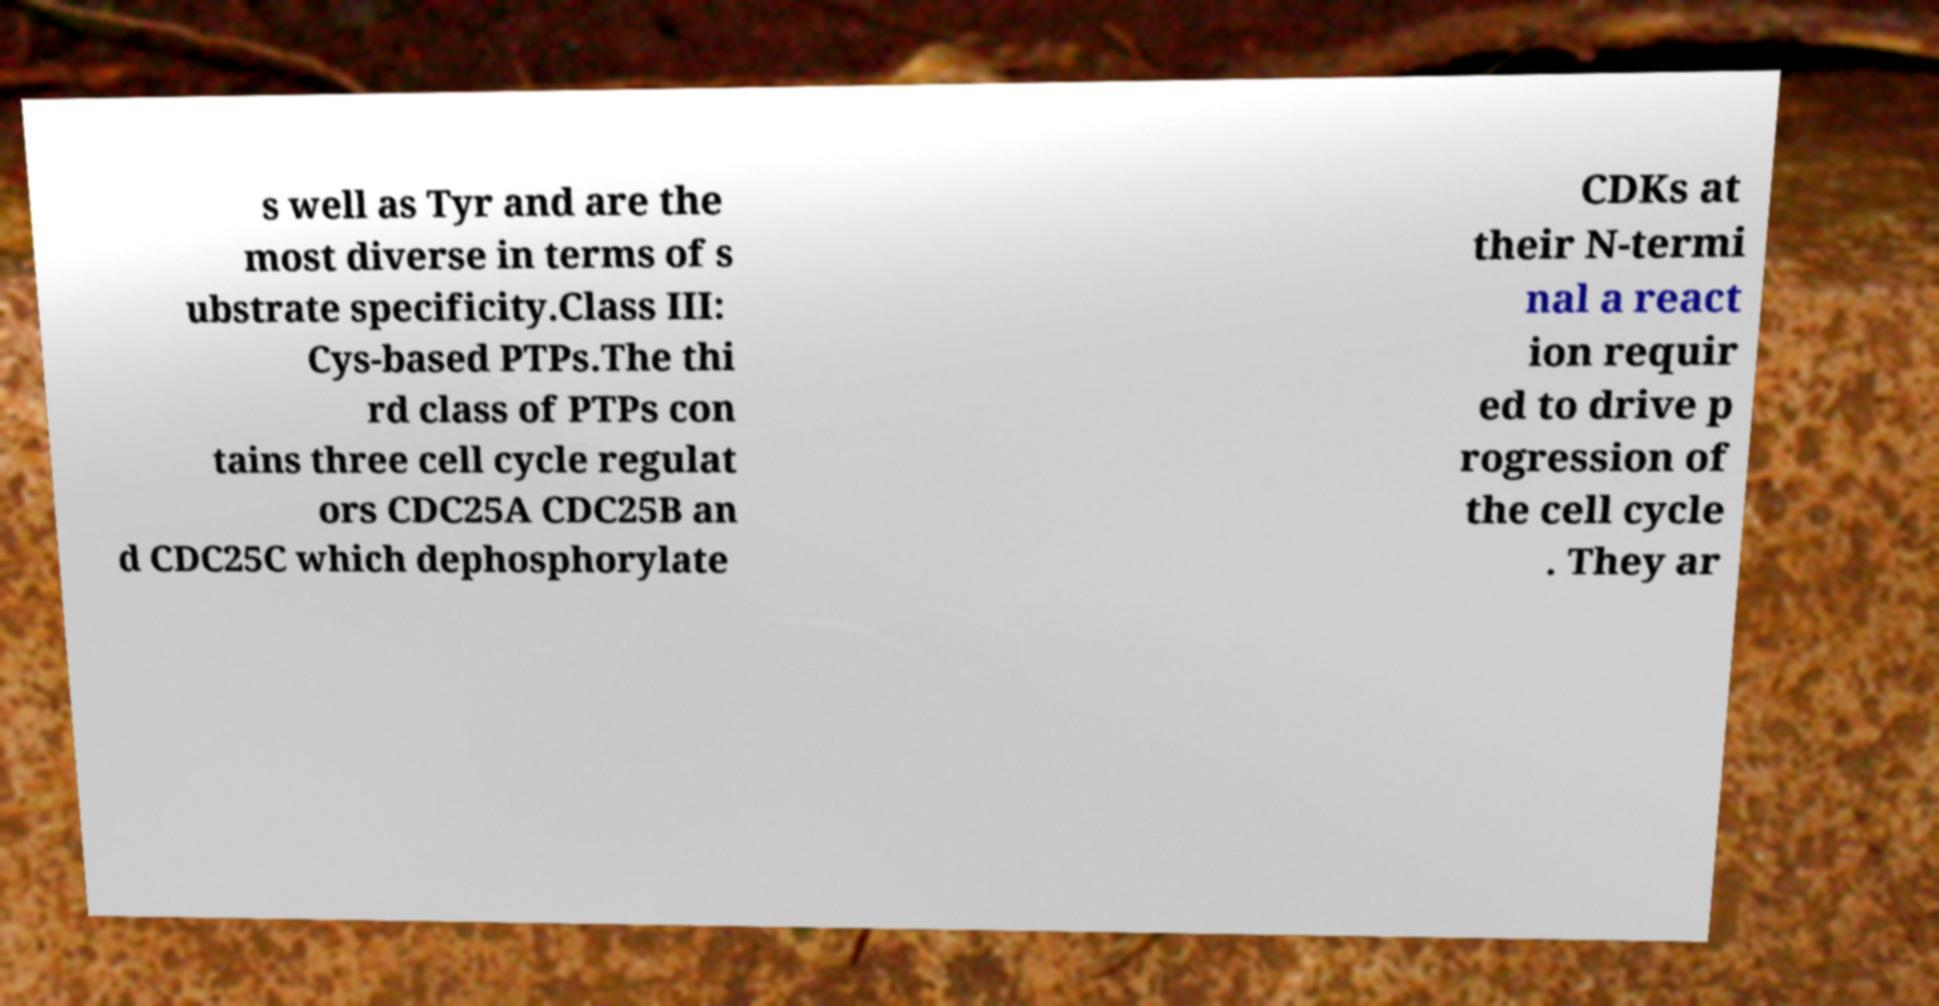There's text embedded in this image that I need extracted. Can you transcribe it verbatim? s well as Tyr and are the most diverse in terms of s ubstrate specificity.Class III: Cys-based PTPs.The thi rd class of PTPs con tains three cell cycle regulat ors CDC25A CDC25B an d CDC25C which dephosphorylate CDKs at their N-termi nal a react ion requir ed to drive p rogression of the cell cycle . They ar 